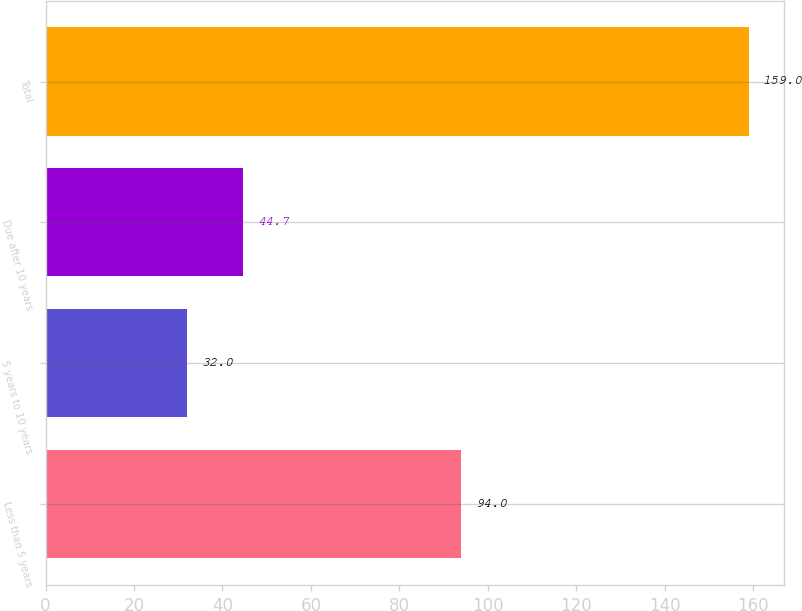Convert chart to OTSL. <chart><loc_0><loc_0><loc_500><loc_500><bar_chart><fcel>Less than 5 years<fcel>5 years to 10 years<fcel>Due after 10 years<fcel>Total<nl><fcel>94<fcel>32<fcel>44.7<fcel>159<nl></chart> 